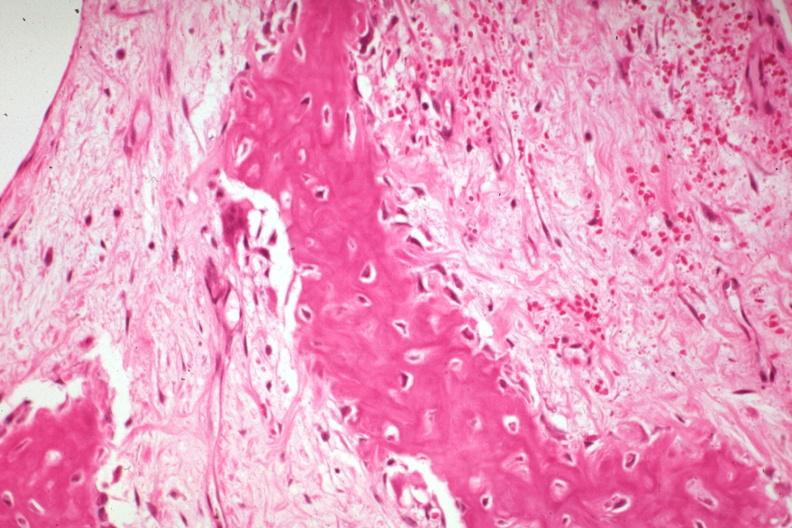what does this image show?
Answer the question using a single word or phrase. High fibrous callus with osteoid and osteoblasts 